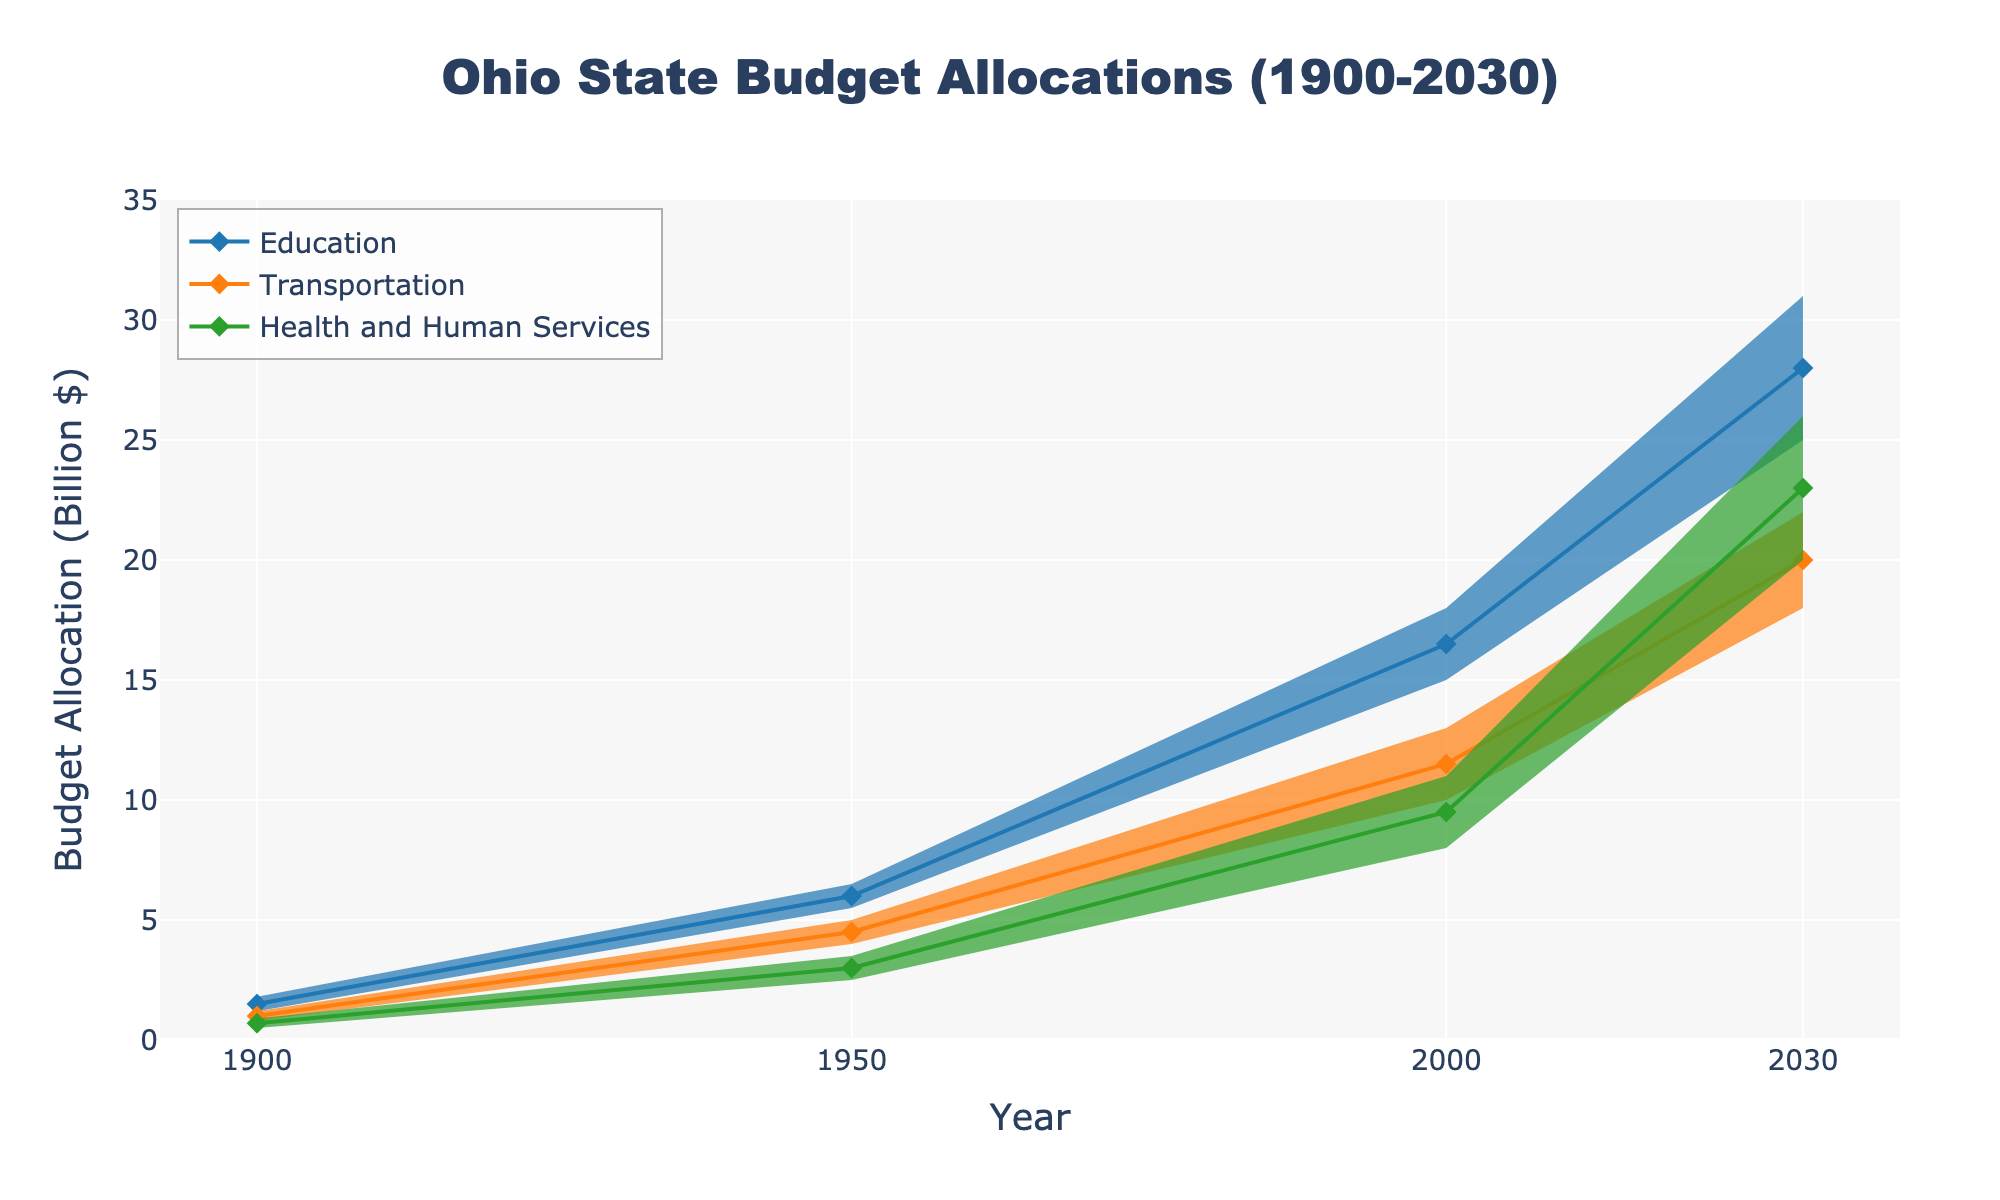What is the title of the figure? The title is located at the top of the chart and provides an overview of what it represents. By looking at the top, you will see the title "Ohio State Budget Allocations (1900-2030)".
Answer: Ohio State Budget Allocations (1900-2030) Which department had the highest median budget allocation in 2000? To find this, locate the year 2000 along the x-axis and compare the median values of all departments. The Education department has the highest median at 16.5 billion dollars.
Answer: Education What is the range of budget allocations for the Health and Human Services department in 2030? The range can be found by looking at the upper and lower bounds. For 2030, the lower bound is 20.0 billion dollars and the upper bound is 26.0 billion dollars, so the range is 6.0 billion dollars.
Answer: 6.0 billion dollars How did the median budget allocation for the Transportation department change from 1950 to 2000? Find the median values for the Transportation department in both years. In 1950, it was 4.5 billion dollars and in 2000, it was 11.5 billion dollars. The change is 11.5 - 4.5 = 7.0 billion dollars.
Answer: 7.0 billion dollars Between which two years did the median budget allocation for Education see the largest increase? By comparing the increments, from 1900 to 1950, it increased by 6.0 - 1.5 = 4.5 billion dollars; from 1950 to 2000, it increased by 16.5 - 6.0 = 10.5 billion dollars; from 2000 to 2030, it increased by 28.0 - 16.5 = 11.5 billion dollars. The largest increase was between 2000 and 2030.
Answer: 2000 and 2030 What is the median budget allocation for Health and Human Services in 1900, 1950, and 2000? Locate the median values for Health and Human Services in the specified years. In 1900, it's 0.7 billion dollars; in 1950, it's 3.0 billion dollars; and in 2000, it's 9.5 billion dollars.
Answer: 0.7, 3.0, and 9.5 billion dollars Which department had the smallest difference between upper and lower bounds in 1900? Compare the differences between the upper and lower bounds for all departments in 1900. Education differs by 1.8 - 1.2 = 0.6 billion dollars, Transportation by 1.2 - 0.8 = 0.4 billion dollars, and Health and Human Services by 0.9 - 0.5 = 0.4 billion dollars. Transportation and Health and Human Services tie for the smallest difference.
Answer: Transportation and Health and Human Services How many data points are there for each department? Each department presents data for four years (1900, 1950, 2000, and 2030). As there are three departments, each department has four data points.
Answer: 4 data points Which department had the second highest median value in 2030? Look at the median values for each department in 2030: Education is 28.0 billion dollars, Transportation is 20.0 billion dollars, and Health and Human Services is 23.0 billion dollars. Health and Human Services has the second highest median value.
Answer: Health and Human Services What is the trend in the median budget allocation for the Education department over the years? Examine the median budget allocation for Education in the years 1900, 1950, 2000, and 2030. The values are 1.5, 6.0, 16.5, and 28.0 billion dollars respectively, indicating a consistent increase over time.
Answer: Increasing trend 